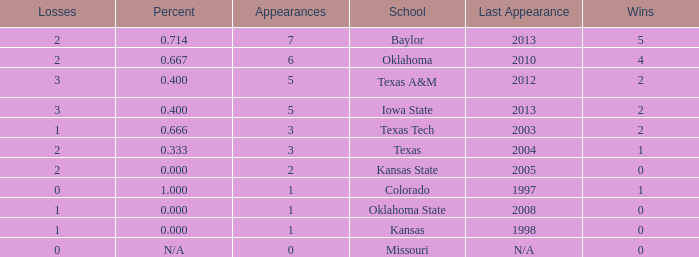How many schools had the win loss ratio of 0.667?  1.0. 